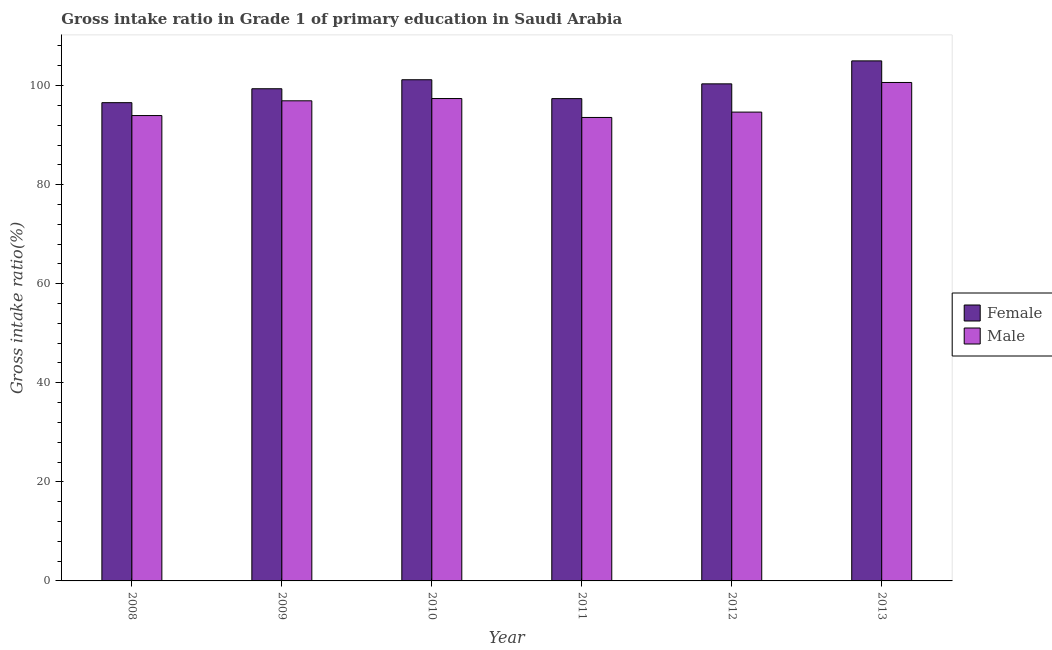How many different coloured bars are there?
Offer a terse response. 2. How many groups of bars are there?
Make the answer very short. 6. Are the number of bars on each tick of the X-axis equal?
Make the answer very short. Yes. How many bars are there on the 1st tick from the left?
Make the answer very short. 2. How many bars are there on the 2nd tick from the right?
Keep it short and to the point. 2. In how many cases, is the number of bars for a given year not equal to the number of legend labels?
Offer a very short reply. 0. What is the gross intake ratio(female) in 2010?
Give a very brief answer. 101.18. Across all years, what is the maximum gross intake ratio(male)?
Offer a terse response. 100.63. Across all years, what is the minimum gross intake ratio(female)?
Make the answer very short. 96.55. In which year was the gross intake ratio(female) maximum?
Keep it short and to the point. 2013. In which year was the gross intake ratio(female) minimum?
Provide a short and direct response. 2008. What is the total gross intake ratio(female) in the graph?
Ensure brevity in your answer.  599.8. What is the difference between the gross intake ratio(female) in 2009 and that in 2011?
Provide a short and direct response. 1.99. What is the difference between the gross intake ratio(male) in 2011 and the gross intake ratio(female) in 2012?
Provide a succinct answer. -1.08. What is the average gross intake ratio(male) per year?
Your answer should be compact. 96.18. What is the ratio of the gross intake ratio(male) in 2008 to that in 2011?
Make the answer very short. 1. Is the gross intake ratio(female) in 2011 less than that in 2012?
Ensure brevity in your answer.  Yes. What is the difference between the highest and the second highest gross intake ratio(female)?
Your response must be concise. 3.81. What is the difference between the highest and the lowest gross intake ratio(female)?
Your answer should be compact. 8.44. Are all the bars in the graph horizontal?
Your response must be concise. No. How many years are there in the graph?
Your answer should be very brief. 6. Are the values on the major ticks of Y-axis written in scientific E-notation?
Your answer should be very brief. No. Does the graph contain any zero values?
Your answer should be very brief. No. How are the legend labels stacked?
Ensure brevity in your answer.  Vertical. What is the title of the graph?
Offer a very short reply. Gross intake ratio in Grade 1 of primary education in Saudi Arabia. Does "Lower secondary education" appear as one of the legend labels in the graph?
Make the answer very short. No. What is the label or title of the Y-axis?
Offer a terse response. Gross intake ratio(%). What is the Gross intake ratio(%) in Female in 2008?
Provide a succinct answer. 96.55. What is the Gross intake ratio(%) of Male in 2008?
Offer a terse response. 93.95. What is the Gross intake ratio(%) in Female in 2009?
Offer a terse response. 99.36. What is the Gross intake ratio(%) of Male in 2009?
Keep it short and to the point. 96.93. What is the Gross intake ratio(%) in Female in 2010?
Your answer should be compact. 101.18. What is the Gross intake ratio(%) in Male in 2010?
Offer a very short reply. 97.39. What is the Gross intake ratio(%) of Female in 2011?
Provide a short and direct response. 97.37. What is the Gross intake ratio(%) of Male in 2011?
Provide a succinct answer. 93.56. What is the Gross intake ratio(%) in Female in 2012?
Give a very brief answer. 100.35. What is the Gross intake ratio(%) in Male in 2012?
Your response must be concise. 94.65. What is the Gross intake ratio(%) of Female in 2013?
Make the answer very short. 104.99. What is the Gross intake ratio(%) in Male in 2013?
Your answer should be very brief. 100.63. Across all years, what is the maximum Gross intake ratio(%) in Female?
Ensure brevity in your answer.  104.99. Across all years, what is the maximum Gross intake ratio(%) in Male?
Provide a succinct answer. 100.63. Across all years, what is the minimum Gross intake ratio(%) in Female?
Keep it short and to the point. 96.55. Across all years, what is the minimum Gross intake ratio(%) of Male?
Keep it short and to the point. 93.56. What is the total Gross intake ratio(%) of Female in the graph?
Keep it short and to the point. 599.8. What is the total Gross intake ratio(%) in Male in the graph?
Ensure brevity in your answer.  577.1. What is the difference between the Gross intake ratio(%) of Female in 2008 and that in 2009?
Your answer should be very brief. -2.81. What is the difference between the Gross intake ratio(%) of Male in 2008 and that in 2009?
Make the answer very short. -2.98. What is the difference between the Gross intake ratio(%) in Female in 2008 and that in 2010?
Make the answer very short. -4.63. What is the difference between the Gross intake ratio(%) in Male in 2008 and that in 2010?
Your response must be concise. -3.44. What is the difference between the Gross intake ratio(%) of Female in 2008 and that in 2011?
Provide a short and direct response. -0.82. What is the difference between the Gross intake ratio(%) of Male in 2008 and that in 2011?
Offer a terse response. 0.39. What is the difference between the Gross intake ratio(%) in Female in 2008 and that in 2012?
Give a very brief answer. -3.8. What is the difference between the Gross intake ratio(%) of Male in 2008 and that in 2012?
Make the answer very short. -0.7. What is the difference between the Gross intake ratio(%) in Female in 2008 and that in 2013?
Your answer should be compact. -8.44. What is the difference between the Gross intake ratio(%) of Male in 2008 and that in 2013?
Keep it short and to the point. -6.68. What is the difference between the Gross intake ratio(%) in Female in 2009 and that in 2010?
Offer a terse response. -1.82. What is the difference between the Gross intake ratio(%) of Male in 2009 and that in 2010?
Your answer should be compact. -0.46. What is the difference between the Gross intake ratio(%) of Female in 2009 and that in 2011?
Your answer should be very brief. 1.99. What is the difference between the Gross intake ratio(%) in Male in 2009 and that in 2011?
Ensure brevity in your answer.  3.36. What is the difference between the Gross intake ratio(%) of Female in 2009 and that in 2012?
Give a very brief answer. -0.99. What is the difference between the Gross intake ratio(%) of Male in 2009 and that in 2012?
Offer a terse response. 2.28. What is the difference between the Gross intake ratio(%) of Female in 2009 and that in 2013?
Make the answer very short. -5.62. What is the difference between the Gross intake ratio(%) of Male in 2009 and that in 2013?
Your response must be concise. -3.7. What is the difference between the Gross intake ratio(%) in Female in 2010 and that in 2011?
Your response must be concise. 3.81. What is the difference between the Gross intake ratio(%) in Male in 2010 and that in 2011?
Provide a short and direct response. 3.82. What is the difference between the Gross intake ratio(%) of Female in 2010 and that in 2012?
Your response must be concise. 0.83. What is the difference between the Gross intake ratio(%) in Male in 2010 and that in 2012?
Give a very brief answer. 2.74. What is the difference between the Gross intake ratio(%) of Female in 2010 and that in 2013?
Your response must be concise. -3.81. What is the difference between the Gross intake ratio(%) of Male in 2010 and that in 2013?
Your response must be concise. -3.24. What is the difference between the Gross intake ratio(%) in Female in 2011 and that in 2012?
Keep it short and to the point. -2.98. What is the difference between the Gross intake ratio(%) in Male in 2011 and that in 2012?
Your answer should be very brief. -1.08. What is the difference between the Gross intake ratio(%) of Female in 2011 and that in 2013?
Offer a very short reply. -7.62. What is the difference between the Gross intake ratio(%) of Male in 2011 and that in 2013?
Your answer should be very brief. -7.06. What is the difference between the Gross intake ratio(%) in Female in 2012 and that in 2013?
Give a very brief answer. -4.64. What is the difference between the Gross intake ratio(%) in Male in 2012 and that in 2013?
Offer a very short reply. -5.98. What is the difference between the Gross intake ratio(%) of Female in 2008 and the Gross intake ratio(%) of Male in 2009?
Keep it short and to the point. -0.38. What is the difference between the Gross intake ratio(%) in Female in 2008 and the Gross intake ratio(%) in Male in 2010?
Keep it short and to the point. -0.83. What is the difference between the Gross intake ratio(%) of Female in 2008 and the Gross intake ratio(%) of Male in 2011?
Make the answer very short. 2.99. What is the difference between the Gross intake ratio(%) of Female in 2008 and the Gross intake ratio(%) of Male in 2012?
Your answer should be very brief. 1.9. What is the difference between the Gross intake ratio(%) of Female in 2008 and the Gross intake ratio(%) of Male in 2013?
Your answer should be compact. -4.07. What is the difference between the Gross intake ratio(%) in Female in 2009 and the Gross intake ratio(%) in Male in 2010?
Give a very brief answer. 1.98. What is the difference between the Gross intake ratio(%) of Female in 2009 and the Gross intake ratio(%) of Male in 2011?
Provide a succinct answer. 5.8. What is the difference between the Gross intake ratio(%) of Female in 2009 and the Gross intake ratio(%) of Male in 2012?
Offer a terse response. 4.71. What is the difference between the Gross intake ratio(%) in Female in 2009 and the Gross intake ratio(%) in Male in 2013?
Your response must be concise. -1.26. What is the difference between the Gross intake ratio(%) in Female in 2010 and the Gross intake ratio(%) in Male in 2011?
Make the answer very short. 7.62. What is the difference between the Gross intake ratio(%) in Female in 2010 and the Gross intake ratio(%) in Male in 2012?
Keep it short and to the point. 6.53. What is the difference between the Gross intake ratio(%) in Female in 2010 and the Gross intake ratio(%) in Male in 2013?
Ensure brevity in your answer.  0.55. What is the difference between the Gross intake ratio(%) in Female in 2011 and the Gross intake ratio(%) in Male in 2012?
Give a very brief answer. 2.72. What is the difference between the Gross intake ratio(%) in Female in 2011 and the Gross intake ratio(%) in Male in 2013?
Your response must be concise. -3.26. What is the difference between the Gross intake ratio(%) in Female in 2012 and the Gross intake ratio(%) in Male in 2013?
Give a very brief answer. -0.28. What is the average Gross intake ratio(%) of Female per year?
Make the answer very short. 99.97. What is the average Gross intake ratio(%) in Male per year?
Provide a succinct answer. 96.18. In the year 2008, what is the difference between the Gross intake ratio(%) of Female and Gross intake ratio(%) of Male?
Offer a very short reply. 2.6. In the year 2009, what is the difference between the Gross intake ratio(%) in Female and Gross intake ratio(%) in Male?
Your answer should be compact. 2.43. In the year 2010, what is the difference between the Gross intake ratio(%) in Female and Gross intake ratio(%) in Male?
Keep it short and to the point. 3.79. In the year 2011, what is the difference between the Gross intake ratio(%) of Female and Gross intake ratio(%) of Male?
Make the answer very short. 3.8. In the year 2012, what is the difference between the Gross intake ratio(%) of Female and Gross intake ratio(%) of Male?
Your answer should be very brief. 5.7. In the year 2013, what is the difference between the Gross intake ratio(%) of Female and Gross intake ratio(%) of Male?
Offer a very short reply. 4.36. What is the ratio of the Gross intake ratio(%) of Female in 2008 to that in 2009?
Provide a short and direct response. 0.97. What is the ratio of the Gross intake ratio(%) in Male in 2008 to that in 2009?
Give a very brief answer. 0.97. What is the ratio of the Gross intake ratio(%) of Female in 2008 to that in 2010?
Provide a short and direct response. 0.95. What is the ratio of the Gross intake ratio(%) in Male in 2008 to that in 2010?
Keep it short and to the point. 0.96. What is the ratio of the Gross intake ratio(%) in Female in 2008 to that in 2011?
Ensure brevity in your answer.  0.99. What is the ratio of the Gross intake ratio(%) of Female in 2008 to that in 2012?
Provide a succinct answer. 0.96. What is the ratio of the Gross intake ratio(%) in Male in 2008 to that in 2012?
Your response must be concise. 0.99. What is the ratio of the Gross intake ratio(%) in Female in 2008 to that in 2013?
Make the answer very short. 0.92. What is the ratio of the Gross intake ratio(%) in Male in 2008 to that in 2013?
Make the answer very short. 0.93. What is the ratio of the Gross intake ratio(%) in Female in 2009 to that in 2010?
Provide a short and direct response. 0.98. What is the ratio of the Gross intake ratio(%) in Male in 2009 to that in 2010?
Keep it short and to the point. 1. What is the ratio of the Gross intake ratio(%) of Female in 2009 to that in 2011?
Provide a short and direct response. 1.02. What is the ratio of the Gross intake ratio(%) in Male in 2009 to that in 2011?
Ensure brevity in your answer.  1.04. What is the ratio of the Gross intake ratio(%) of Female in 2009 to that in 2012?
Keep it short and to the point. 0.99. What is the ratio of the Gross intake ratio(%) in Male in 2009 to that in 2012?
Provide a short and direct response. 1.02. What is the ratio of the Gross intake ratio(%) in Female in 2009 to that in 2013?
Ensure brevity in your answer.  0.95. What is the ratio of the Gross intake ratio(%) of Male in 2009 to that in 2013?
Offer a very short reply. 0.96. What is the ratio of the Gross intake ratio(%) of Female in 2010 to that in 2011?
Keep it short and to the point. 1.04. What is the ratio of the Gross intake ratio(%) of Male in 2010 to that in 2011?
Make the answer very short. 1.04. What is the ratio of the Gross intake ratio(%) in Female in 2010 to that in 2012?
Keep it short and to the point. 1.01. What is the ratio of the Gross intake ratio(%) of Male in 2010 to that in 2012?
Keep it short and to the point. 1.03. What is the ratio of the Gross intake ratio(%) of Female in 2010 to that in 2013?
Offer a terse response. 0.96. What is the ratio of the Gross intake ratio(%) of Male in 2010 to that in 2013?
Your response must be concise. 0.97. What is the ratio of the Gross intake ratio(%) in Female in 2011 to that in 2012?
Your response must be concise. 0.97. What is the ratio of the Gross intake ratio(%) of Female in 2011 to that in 2013?
Keep it short and to the point. 0.93. What is the ratio of the Gross intake ratio(%) in Male in 2011 to that in 2013?
Your answer should be compact. 0.93. What is the ratio of the Gross intake ratio(%) in Female in 2012 to that in 2013?
Make the answer very short. 0.96. What is the ratio of the Gross intake ratio(%) of Male in 2012 to that in 2013?
Offer a very short reply. 0.94. What is the difference between the highest and the second highest Gross intake ratio(%) of Female?
Make the answer very short. 3.81. What is the difference between the highest and the second highest Gross intake ratio(%) in Male?
Make the answer very short. 3.24. What is the difference between the highest and the lowest Gross intake ratio(%) in Female?
Your response must be concise. 8.44. What is the difference between the highest and the lowest Gross intake ratio(%) in Male?
Provide a short and direct response. 7.06. 